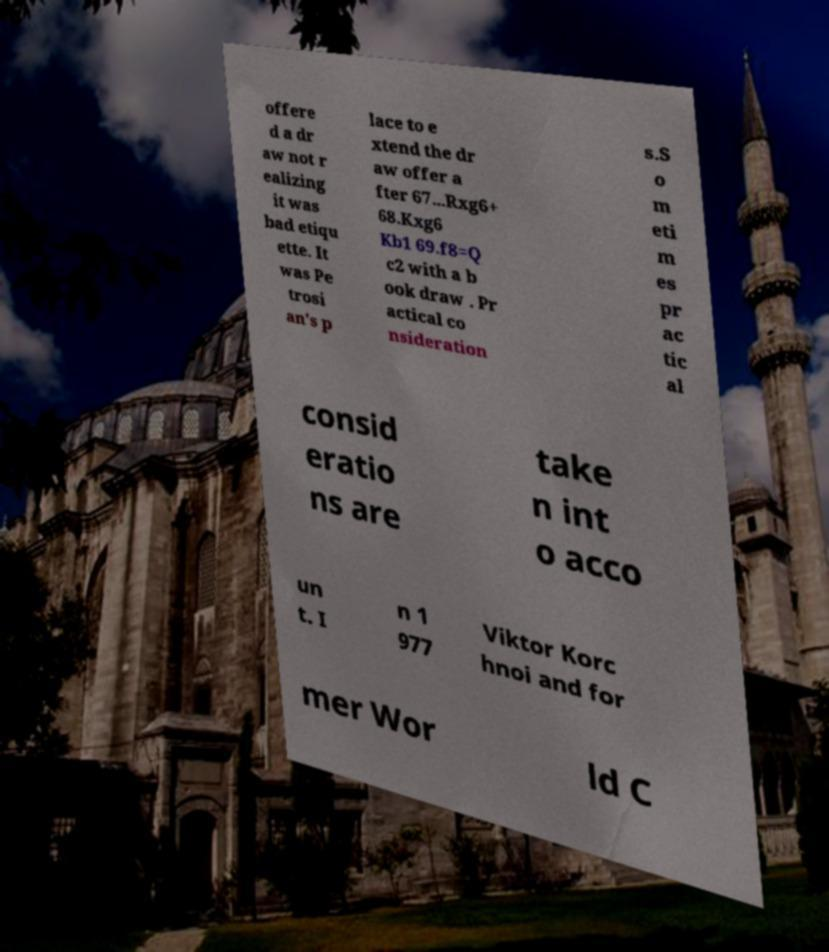For documentation purposes, I need the text within this image transcribed. Could you provide that? offere d a dr aw not r ealizing it was bad etiqu ette. It was Pe trosi an's p lace to e xtend the dr aw offer a fter 67...Rxg6+ 68.Kxg6 Kb1 69.f8=Q c2 with a b ook draw . Pr actical co nsideration s.S o m eti m es pr ac tic al consid eratio ns are take n int o acco un t. I n 1 977 Viktor Korc hnoi and for mer Wor ld C 